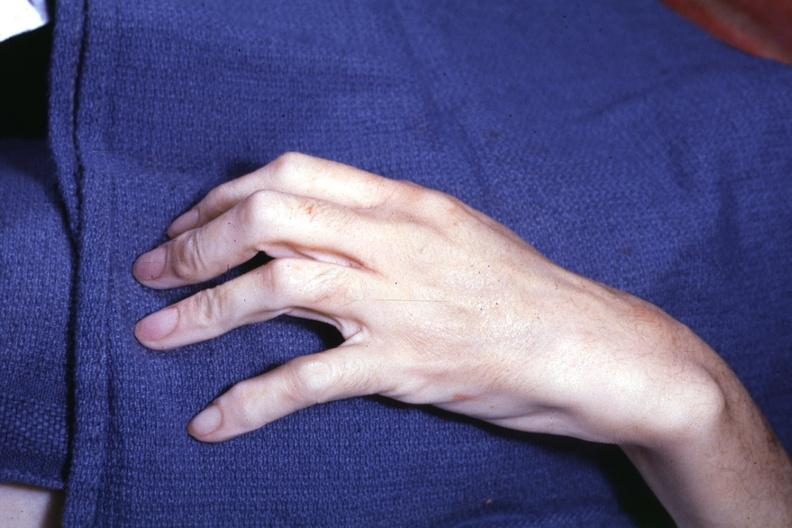how does long fingers interesting case see slides?
Answer the question using a single word or phrase. Other 